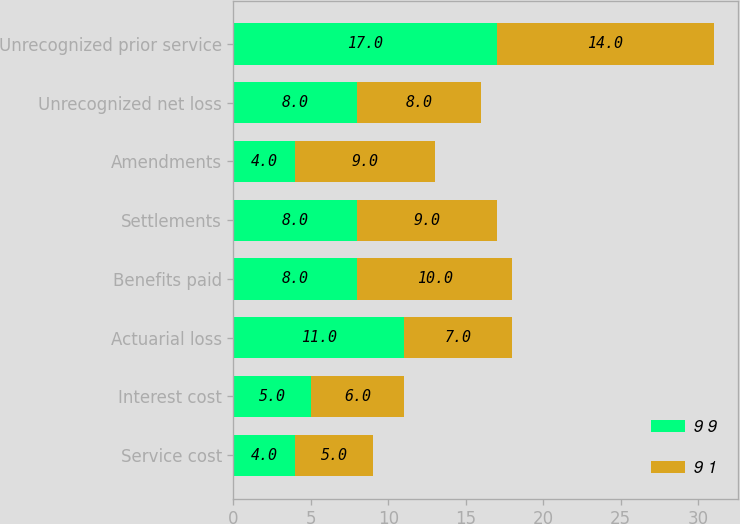Convert chart. <chart><loc_0><loc_0><loc_500><loc_500><stacked_bar_chart><ecel><fcel>Service cost<fcel>Interest cost<fcel>Actuarial loss<fcel>Benefits paid<fcel>Settlements<fcel>Amendments<fcel>Unrecognized net loss<fcel>Unrecognized prior service<nl><fcel>9 9<fcel>4<fcel>5<fcel>11<fcel>8<fcel>8<fcel>4<fcel>8<fcel>17<nl><fcel>9 1<fcel>5<fcel>6<fcel>7<fcel>10<fcel>9<fcel>9<fcel>8<fcel>14<nl></chart> 